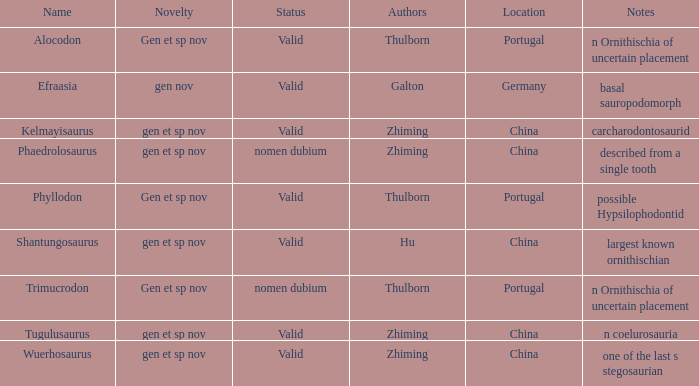What makes the dinosaur, named by galton, unique? Gen nov. 